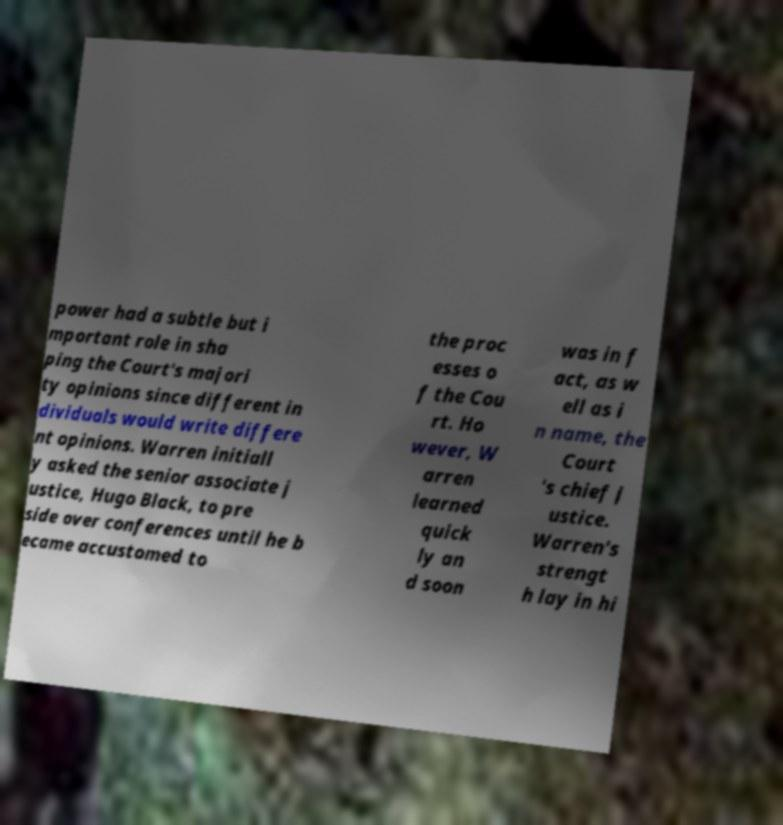Could you extract and type out the text from this image? power had a subtle but i mportant role in sha ping the Court's majori ty opinions since different in dividuals would write differe nt opinions. Warren initiall y asked the senior associate j ustice, Hugo Black, to pre side over conferences until he b ecame accustomed to the proc esses o f the Cou rt. Ho wever, W arren learned quick ly an d soon was in f act, as w ell as i n name, the Court 's chief j ustice. Warren's strengt h lay in hi 